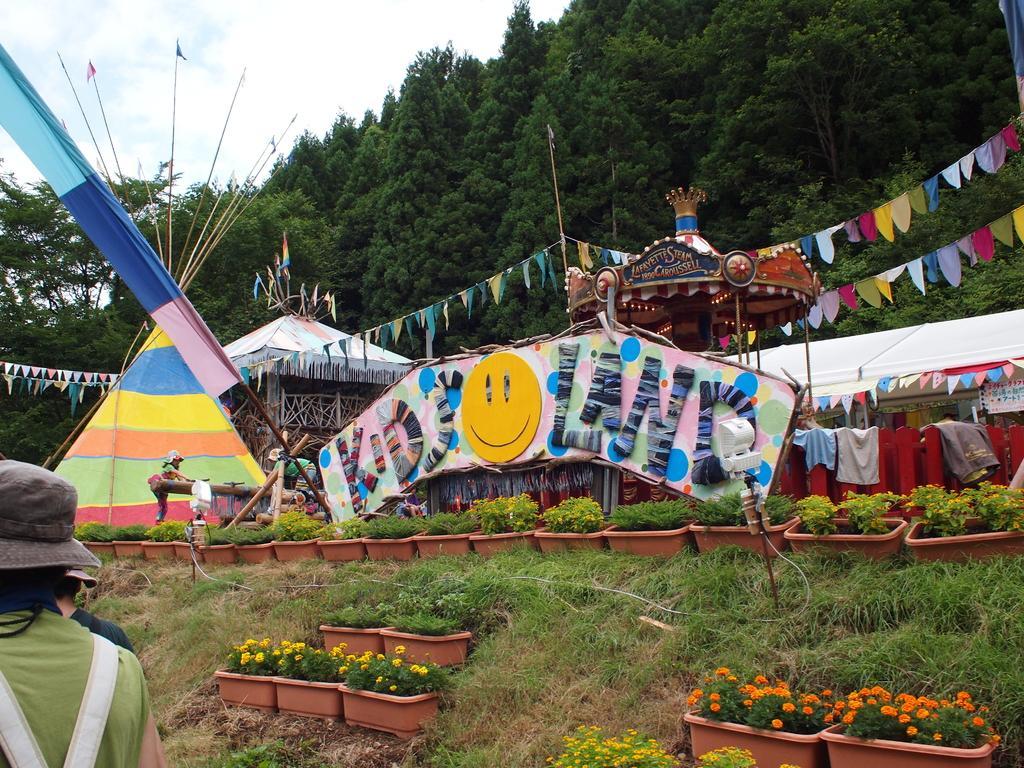Can you describe this image briefly? Here we can see plants, flowers, grass, flags, board, sheds, and two persons. In the background there are trees and sky. 